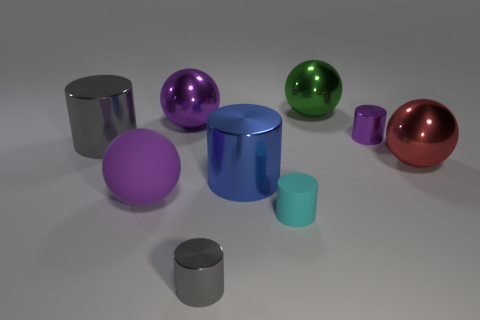Subtract all matte balls. How many balls are left? 3 Subtract all gray cylinders. How many cylinders are left? 3 Subtract all cylinders. How many objects are left? 4 Subtract 0 yellow spheres. How many objects are left? 9 Subtract 1 cylinders. How many cylinders are left? 4 Subtract all gray cylinders. Subtract all yellow cubes. How many cylinders are left? 3 Subtract all cyan cylinders. How many red balls are left? 1 Subtract all big green metal blocks. Subtract all tiny gray objects. How many objects are left? 8 Add 7 cyan objects. How many cyan objects are left? 8 Add 3 matte spheres. How many matte spheres exist? 4 